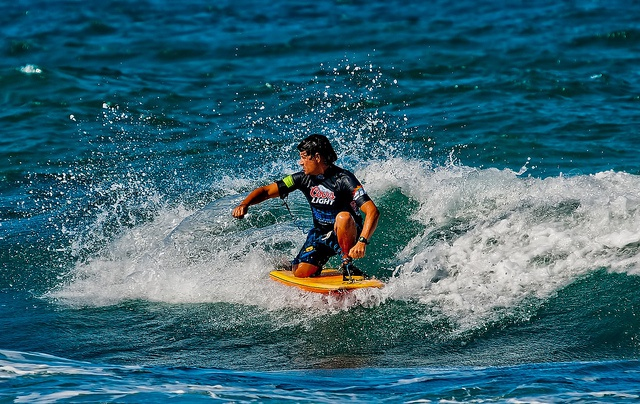Describe the objects in this image and their specific colors. I can see people in blue, black, maroon, and red tones and surfboard in blue, orange, red, tan, and maroon tones in this image. 